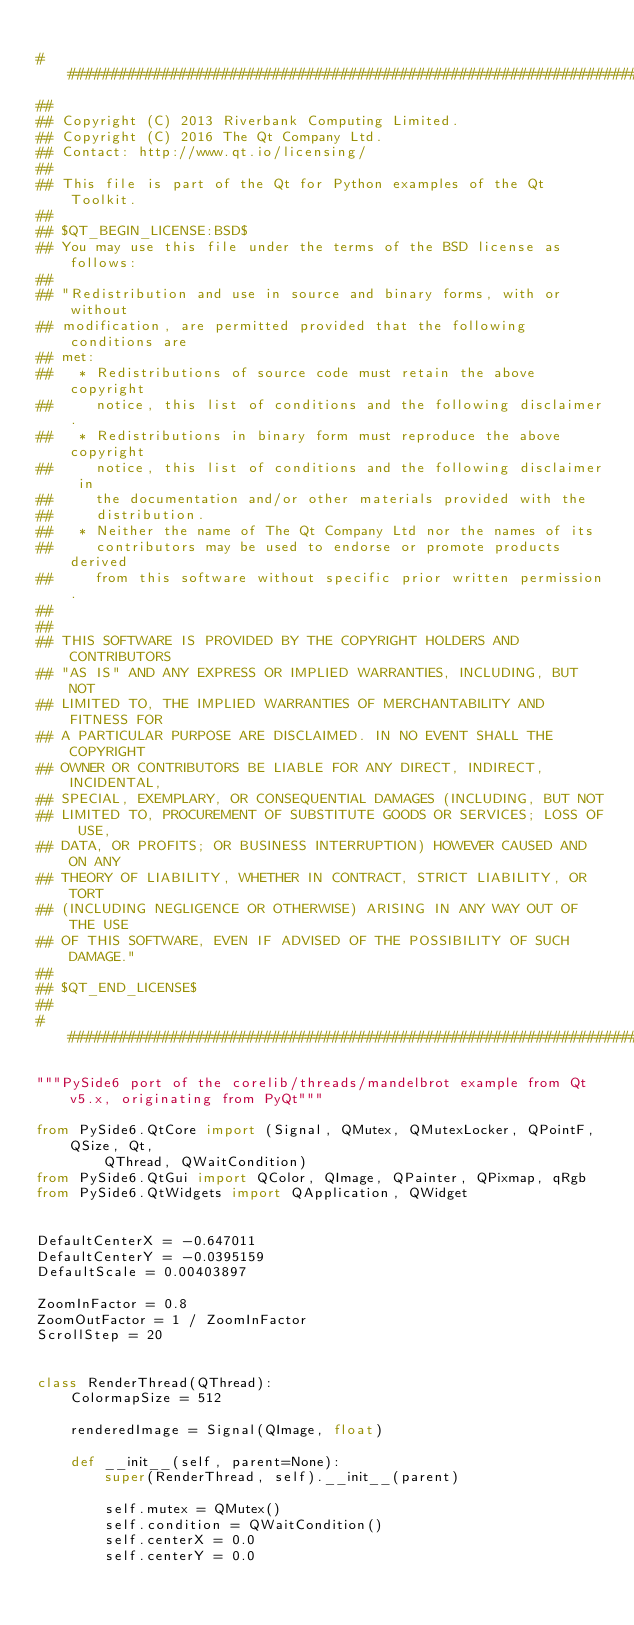Convert code to text. <code><loc_0><loc_0><loc_500><loc_500><_Python_>
#############################################################################
##
## Copyright (C) 2013 Riverbank Computing Limited.
## Copyright (C) 2016 The Qt Company Ltd.
## Contact: http://www.qt.io/licensing/
##
## This file is part of the Qt for Python examples of the Qt Toolkit.
##
## $QT_BEGIN_LICENSE:BSD$
## You may use this file under the terms of the BSD license as follows:
##
## "Redistribution and use in source and binary forms, with or without
## modification, are permitted provided that the following conditions are
## met:
##   * Redistributions of source code must retain the above copyright
##     notice, this list of conditions and the following disclaimer.
##   * Redistributions in binary form must reproduce the above copyright
##     notice, this list of conditions and the following disclaimer in
##     the documentation and/or other materials provided with the
##     distribution.
##   * Neither the name of The Qt Company Ltd nor the names of its
##     contributors may be used to endorse or promote products derived
##     from this software without specific prior written permission.
##
##
## THIS SOFTWARE IS PROVIDED BY THE COPYRIGHT HOLDERS AND CONTRIBUTORS
## "AS IS" AND ANY EXPRESS OR IMPLIED WARRANTIES, INCLUDING, BUT NOT
## LIMITED TO, THE IMPLIED WARRANTIES OF MERCHANTABILITY AND FITNESS FOR
## A PARTICULAR PURPOSE ARE DISCLAIMED. IN NO EVENT SHALL THE COPYRIGHT
## OWNER OR CONTRIBUTORS BE LIABLE FOR ANY DIRECT, INDIRECT, INCIDENTAL,
## SPECIAL, EXEMPLARY, OR CONSEQUENTIAL DAMAGES (INCLUDING, BUT NOT
## LIMITED TO, PROCUREMENT OF SUBSTITUTE GOODS OR SERVICES; LOSS OF USE,
## DATA, OR PROFITS; OR BUSINESS INTERRUPTION) HOWEVER CAUSED AND ON ANY
## THEORY OF LIABILITY, WHETHER IN CONTRACT, STRICT LIABILITY, OR TORT
## (INCLUDING NEGLIGENCE OR OTHERWISE) ARISING IN ANY WAY OUT OF THE USE
## OF THIS SOFTWARE, EVEN IF ADVISED OF THE POSSIBILITY OF SUCH DAMAGE."
##
## $QT_END_LICENSE$
##
#############################################################################

"""PySide6 port of the corelib/threads/mandelbrot example from Qt v5.x, originating from PyQt"""

from PySide6.QtCore import (Signal, QMutex, QMutexLocker, QPointF, QSize, Qt,
        QThread, QWaitCondition)
from PySide6.QtGui import QColor, QImage, QPainter, QPixmap, qRgb
from PySide6.QtWidgets import QApplication, QWidget


DefaultCenterX = -0.647011
DefaultCenterY = -0.0395159
DefaultScale = 0.00403897

ZoomInFactor = 0.8
ZoomOutFactor = 1 / ZoomInFactor
ScrollStep = 20


class RenderThread(QThread):
    ColormapSize = 512

    renderedImage = Signal(QImage, float)

    def __init__(self, parent=None):
        super(RenderThread, self).__init__(parent)

        self.mutex = QMutex()
        self.condition = QWaitCondition()
        self.centerX = 0.0
        self.centerY = 0.0</code> 